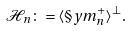Convert formula to latex. <formula><loc_0><loc_0><loc_500><loc_500>\mathcal { H } _ { n } \colon = \langle \S y m _ { n } ^ { + } \rangle ^ { \perp } .</formula> 